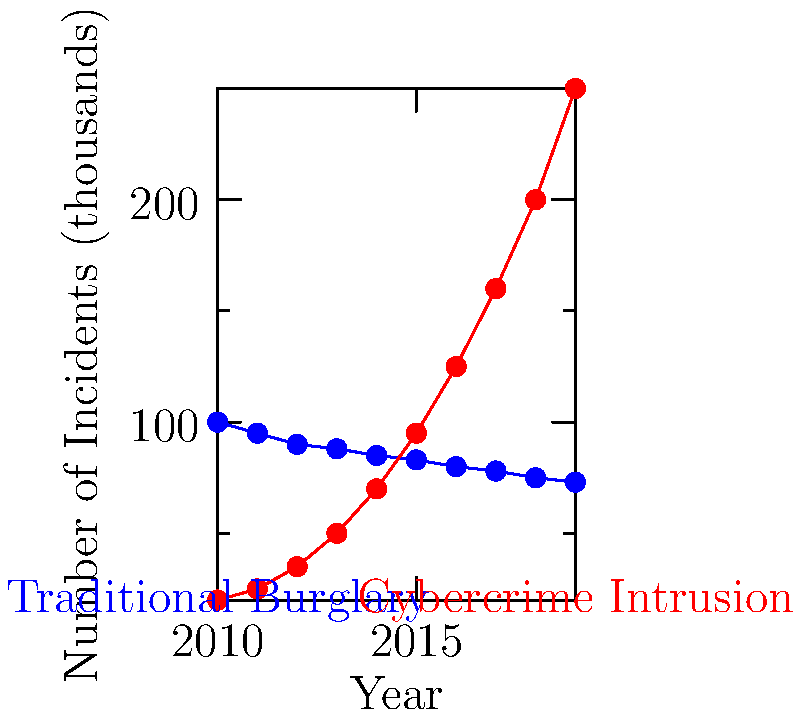Analyze the line graph comparing traditional burglary patterns to cybercrime intrusion trends from 2010 to 2019. What key observation can be made about the relationship between these two types of criminal activities, and what implications might this have for law enforcement strategies? To answer this question, let's analyze the graph step-by-step:

1. Traditional Burglary Trend:
   - The blue line represents traditional burglary incidents.
   - It shows a steady decline from 2010 to 2019.
   - The number of incidents decreased from about 100,000 in 2010 to 73,000 in 2019.

2. Cybercrime Intrusion Trend:
   - The red line represents cybercrime intrusion incidents.
   - It shows a dramatic increase from 2010 to 2019.
   - The number of incidents rose from about 20,000 in 2010 to 250,000 in 2019.

3. Comparison of Trends:
   - The trends are inverse to each other.
   - As traditional burglary decreases, cybercrime intrusions increase.
   - The lines intersect around 2014-2015, indicating a shift in the predominant type of crime.

4. Key Observation:
   - There is a clear shift from traditional burglary to cybercrime intrusions over the decade.
   - By 2019, cybercrime intrusions are more than three times as common as traditional burglaries.

5. Implications for Law Enforcement:
   - Resources and training may need to be reallocated from traditional burglary prevention to cybercrime prevention and investigation.
   - New strategies and technologies will be required to combat the rising threat of cybercrime.
   - Collaboration between traditional law enforcement and cybersecurity experts will become increasingly important.

The key observation is the inverse relationship between traditional burglary and cybercrime intrusion trends, indicating a significant shift in criminal activity from physical to digital spaces.
Answer: Inverse relationship between traditional burglary and cybercrime trends, indicating a shift from physical to digital criminal activity. 